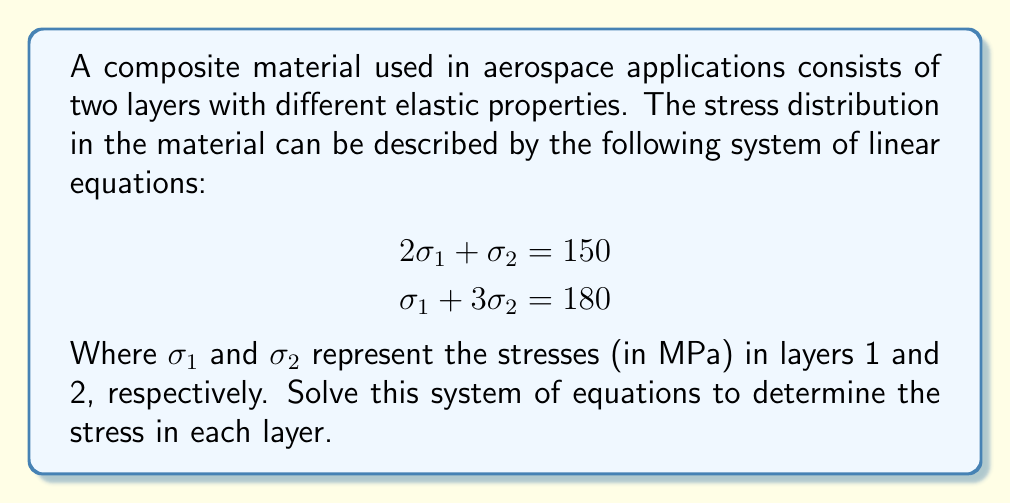Teach me how to tackle this problem. To solve this system of linear equations, we can use the substitution method:

1) From the first equation, express $\sigma_1$ in terms of $\sigma_2$:
   $$2\sigma_1 + \sigma_2 = 150$$
   $$2\sigma_1 = 150 - \sigma_2$$
   $$\sigma_1 = 75 - \frac{1}{2}\sigma_2$$

2) Substitute this expression for $\sigma_1$ into the second equation:
   $$\sigma_1 + 3\sigma_2 = 180$$
   $$(75 - \frac{1}{2}\sigma_2) + 3\sigma_2 = 180$$

3) Simplify:
   $$75 - \frac{1}{2}\sigma_2 + 3\sigma_2 = 180$$
   $$75 + \frac{5}{2}\sigma_2 = 180$$

4) Solve for $\sigma_2$:
   $$\frac{5}{2}\sigma_2 = 105$$
   $$\sigma_2 = 42$$

5) Now that we know $\sigma_2$, substitute back to find $\sigma_1$:
   $$\sigma_1 = 75 - \frac{1}{2}\sigma_2 = 75 - \frac{1}{2}(42) = 54$$

Therefore, the stress in layer 1 ($\sigma_1$) is 54 MPa, and the stress in layer 2 ($\sigma_2$) is 42 MPa.
Answer: $\sigma_1 = 54$ MPa, $\sigma_2 = 42$ MPa 